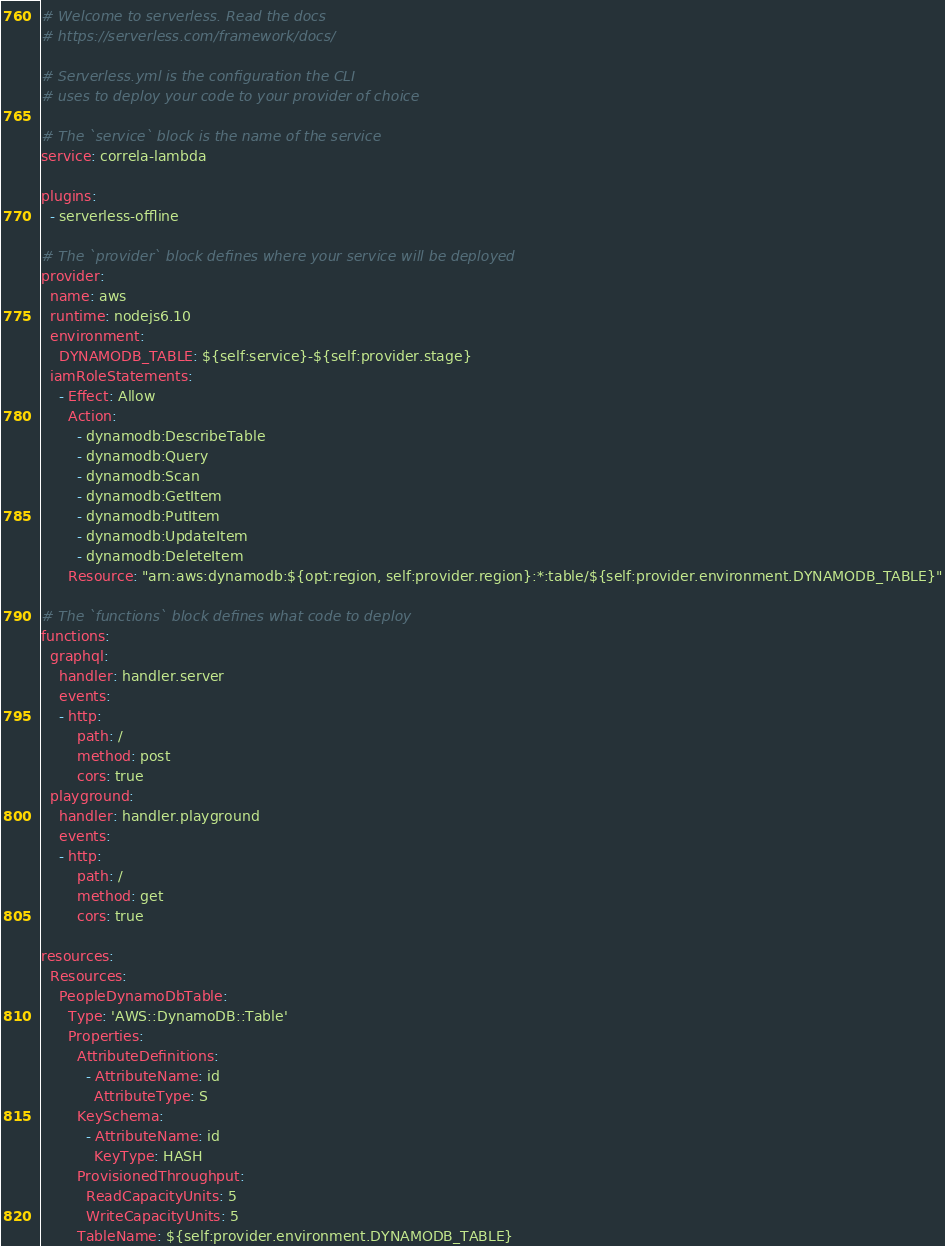<code> <loc_0><loc_0><loc_500><loc_500><_YAML_># Welcome to serverless. Read the docs
# https://serverless.com/framework/docs/

# Serverless.yml is the configuration the CLI
# uses to deploy your code to your provider of choice

# The `service` block is the name of the service
service: correla-lambda

plugins:
  - serverless-offline

# The `provider` block defines where your service will be deployed
provider:
  name: aws
  runtime: nodejs6.10
  environment:
    DYNAMODB_TABLE: ${self:service}-${self:provider.stage}
  iamRoleStatements:
    - Effect: Allow
      Action:
        - dynamodb:DescribeTable
        - dynamodb:Query
        - dynamodb:Scan
        - dynamodb:GetItem
        - dynamodb:PutItem
        - dynamodb:UpdateItem
        - dynamodb:DeleteItem
      Resource: "arn:aws:dynamodb:${opt:region, self:provider.region}:*:table/${self:provider.environment.DYNAMODB_TABLE}"

# The `functions` block defines what code to deploy
functions:
  graphql:
    handler: handler.server
    events:
    - http:
        path: /
        method: post
        cors: true
  playground:
    handler: handler.playground
    events:
    - http:
        path: /
        method: get
        cors: true

resources:
  Resources:
    PeopleDynamoDbTable:
      Type: 'AWS::DynamoDB::Table'
      Properties:
        AttributeDefinitions:
          - AttributeName: id
            AttributeType: S
        KeySchema:
          - AttributeName: id
            KeyType: HASH
        ProvisionedThroughput:
          ReadCapacityUnits: 5
          WriteCapacityUnits: 5
        TableName: ${self:provider.environment.DYNAMODB_TABLE}
</code> 